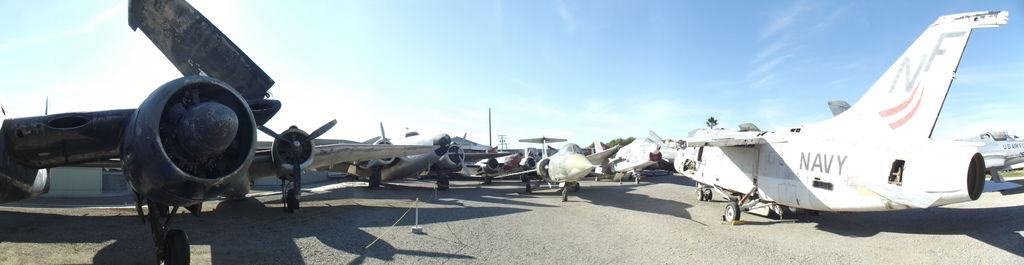Provide a one-sentence caption for the provided image. a plane that has the letters NF on it. 